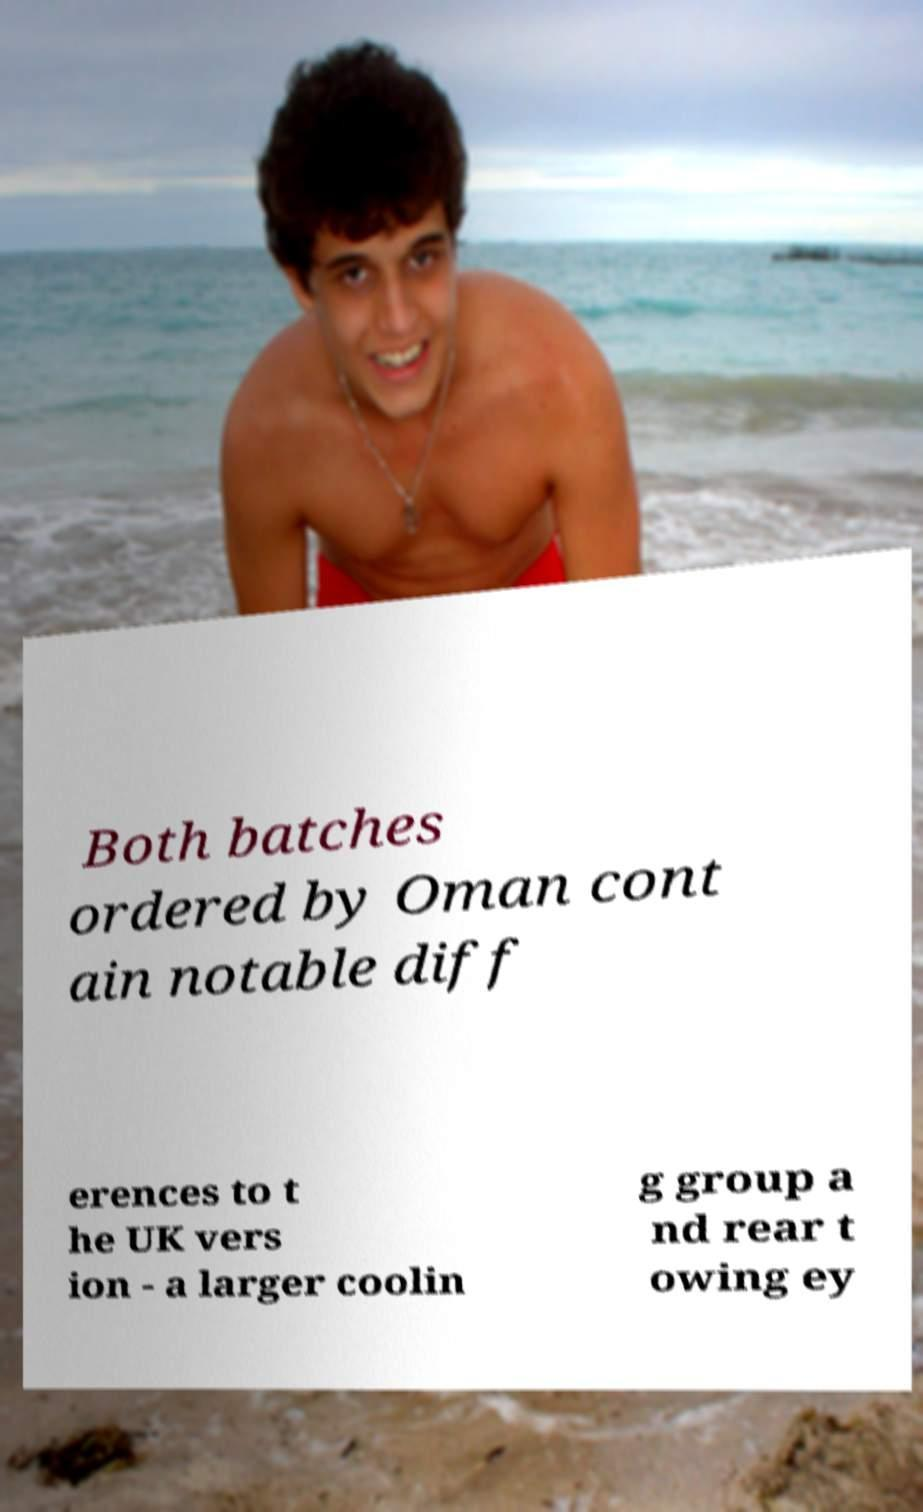Can you accurately transcribe the text from the provided image for me? Both batches ordered by Oman cont ain notable diff erences to t he UK vers ion - a larger coolin g group a nd rear t owing ey 